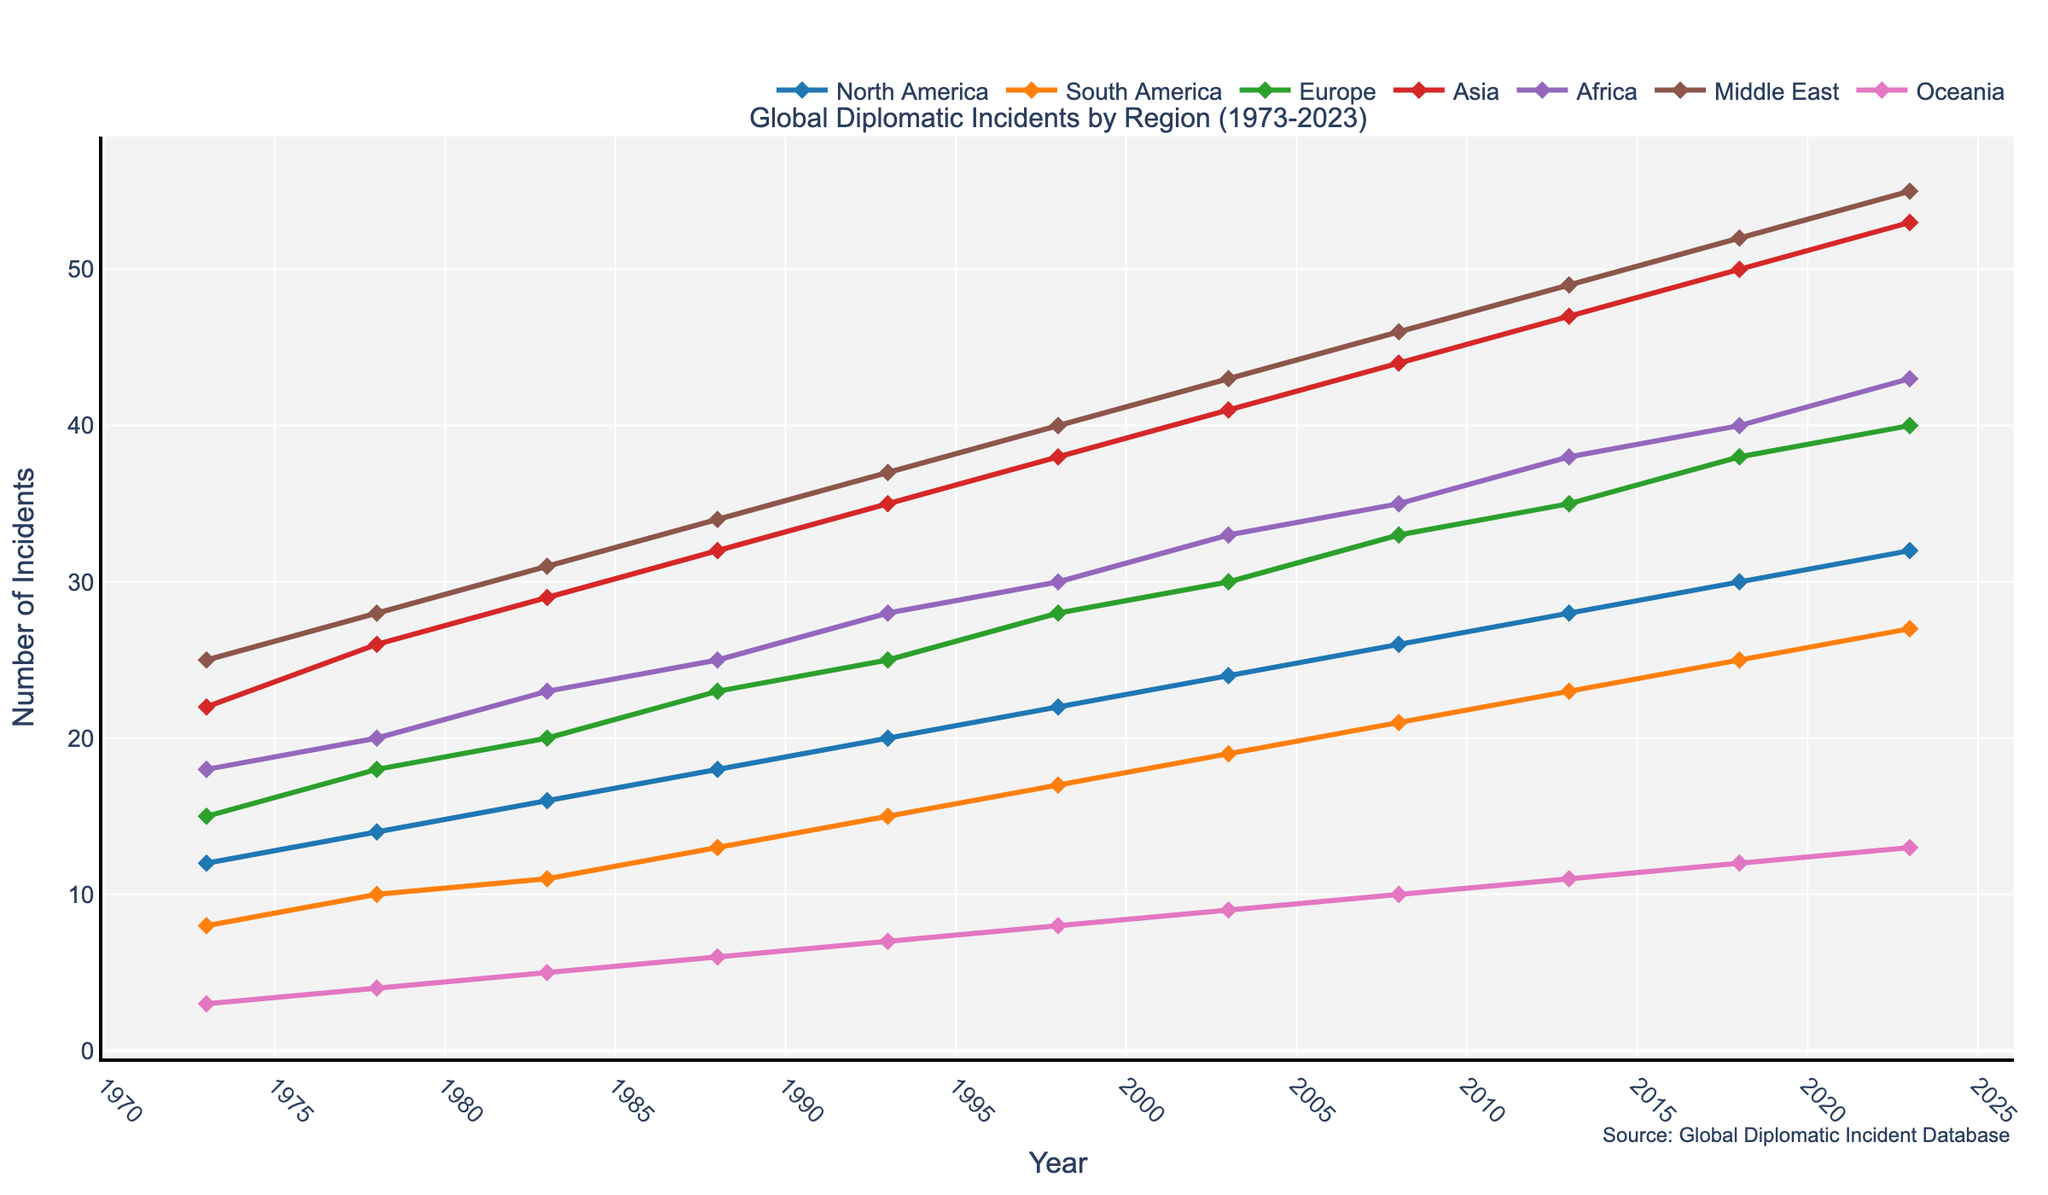What region had the highest number of diplomatic incidents in 2023? Looking at the line chart, observe the data points at the year 2023 for each region. The 'Middle East' line reaches the highest point compared to other regions.
Answer: Middle East Compare the number of incidents in North America and South America in 1993 and 2023. How much have they increased in each region? For North America in 1993, the value is 20 and in 2023 it is 32, so the increase is 32 - 20 = 12. For South America in 1993, the value is 15 and in 2023 it is 27, so the increase is 27 - 15 = 12.
Answer: Both increased by 12 Which region had the smallest increase in diplomatic incidents from 1973 to 2023? Calculate the difference for each region between 1973 and 2023: North America (32-12=20), South America (27-8=19), Europe (40-15=25), Asia (53-22=31), Africa (43-18=25), Middle East (55-25=30), Oceania (13-3=10). Oceania has the smallest increase of 10.
Answer: Oceania In which period did Asia see the largest increase in diplomatic incidents, and by how many incidents did it increase? By tracking the slope of the line for Asia, the largest change appears between 1978 (26) and 1983 (29), with an increase of 3 incidents.
Answer: 1978 to 1983, 3 incidents What is the total number of reported incidents in 1988 across all regions? Add the values for each region in 1988: North America (18) + South America (13) + Europe (23) + Asia (32) + Africa (25) + Middle East (34) + Oceania (6). Total = 18 + 13 + 23 + 32 + 25 + 34 + 6 = 151.
Answer: 151 How does the trend in Europe compare to Asia between 1973 and 2023? The lines for both regions show an increasing trend over the years. However, the slope for Asia is steeper, indicating a faster rate of increase compared to Europe.
Answer: Asia increases faster than Europe What is the average number of incidents for Africa from 1973 to 2023? Sum the values for Africa across all years (18+20+23+25+28+30+33+35+38+40+43) = 333, and divide by the number of years (11). The average is 333 / 11 ≈ 30.27.
Answer: 30.27 Which two regions had almost equal number of incidents in 2008, and what were their values? Looking at the year 2008, South America (21) and Africa (35) are quite different. However, by comparing Europe (33) and Asia (44), these values are closer. Therefore, the closest are South America and North America at (21 and 26).
Answer: South America (21) and North America (26) What is the difference in the number of incidents between the Middle East and Europe in 1973 and 2023? Calculate the differences for both years: 1973 Middle East (25) - Europe (15) = 10; 2023 Middle East (55) - Europe (40) = 15. The differences are 10 and 15, respectively.
Answer: In 1973: 10, In 2023: 15 